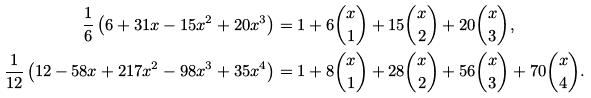Convert formula to latex. <formula><loc_0><loc_0><loc_500><loc_500>\frac { 1 } { 6 } \left ( 6 + 3 1 x - 1 5 { x ^ { 2 } } + 2 0 { x ^ { 3 } } \right ) & = 1 + 6 \binom { x } { 1 } + 1 5 \binom { x } { 2 } + 2 0 \binom { x } { 3 } , \\ \frac { 1 } { 1 2 } \left ( 1 2 - 5 8 x + 2 1 7 { x ^ { 2 } } - 9 8 { x ^ { 3 } } + 3 5 { x ^ { 4 } } \right ) & = 1 + 8 \binom { x } { 1 } + 2 8 \binom { x } { 2 } + 5 6 \binom { x } { 3 } + 7 0 \binom { x } { 4 } .</formula> 